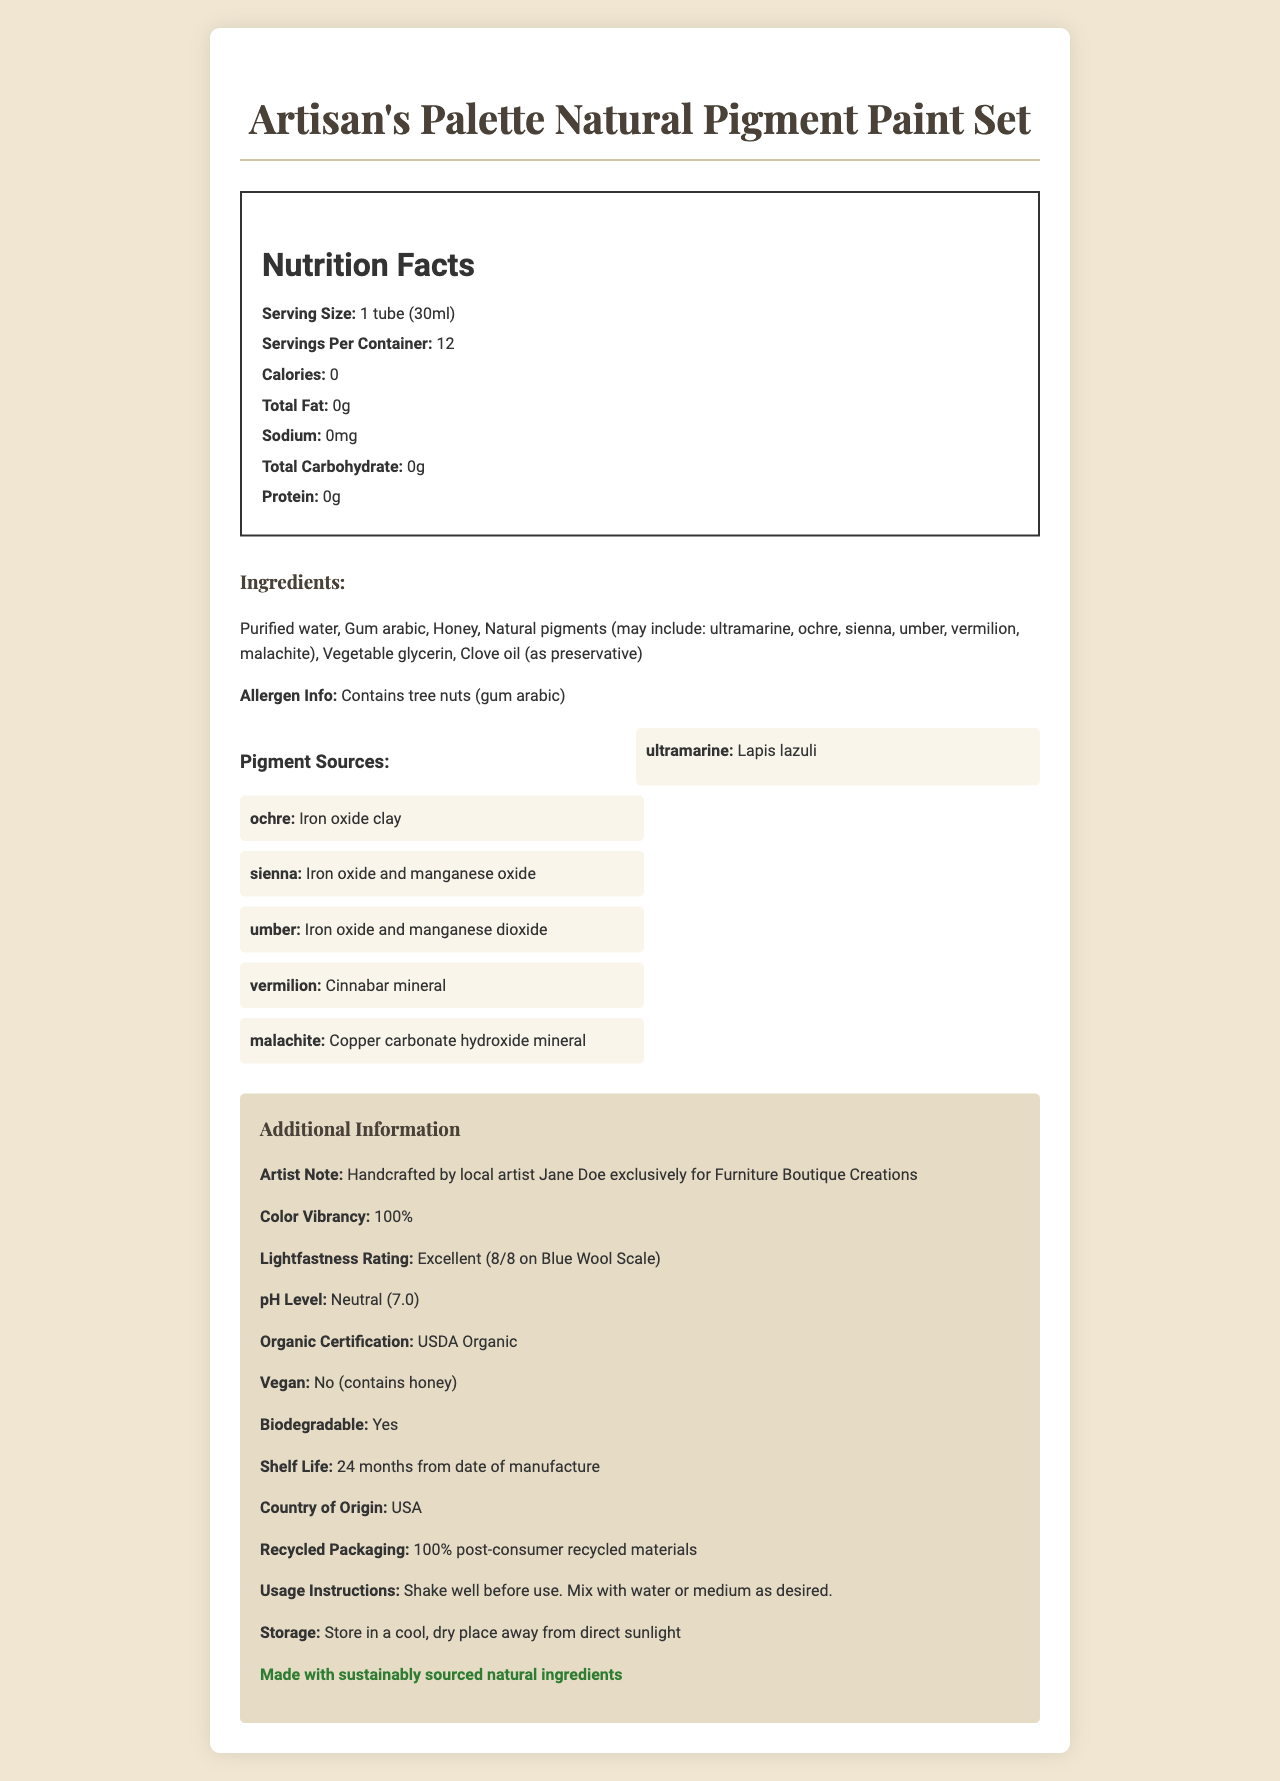what is the serving size of the paint set? The document states that the serving size of the "Artisan's Palette Natural Pigment Paint Set" is 1 tube (30ml).
Answer: 1 tube (30ml) how many servings per container are there? The document specifies that there are 12 servings per container.
Answer: 12 what are the natural pigment sources mentioned in the document? The pigment sources listed in the document for different colors include Lapis lazuli, Iron oxide clay, Iron oxide and manganese oxide, Iron oxide and manganese dioxide, Cinnabar mineral, and Copper carbonate hydroxide mineral.
Answer: Lapis lazuli, Iron oxide clay, Iron oxide and manganese oxide, Iron oxide and manganese dioxide, Cinnabar mineral, Copper carbonate hydroxide mineral who handcrafted the paint set? According to the artist note in the document, the paint set was handcrafted by local artist Jane Doe exclusively for Furniture Boutique Creations.
Answer: Jane Doe what is the lightfastness rating of the paint set? The document mentions that the lightfastness rating of the paint set is Excellent, rated 8/8 on the Blue Wool Scale.
Answer: Excellent (8/8 on Blue Wool Scale) which of the following ingredients is used as a preservative in the paint set? A. Honey B. Vegetable glycerin C. Clove oil D. Purified water The document lists clove oil as the preservative among the ingredients.
Answer: C. Clove oil what is the pH level of the paint set? A. Acidic (5.5) B. Neutral (7.0) C. Alkaline (8.5) The document indicates that the pH level of the paint set is Neutral (7.0).
Answer: B. Neutral (7.0) does the paint set contain any tree nuts? The document specifies in the allergen information section that the paint set contains tree nuts (gum arabic).
Answer: Yes is the paint set vegan-friendly? The document explicitly states that the paint set is not vegan as it contains honey.
Answer: No describe the entire document. The document showcases the Artisan's Palette Natural Pigment Paint Set, highlighting various attributes such as serving size, ingredient list, pigment sources, artist note, and eco-friendly aspects. It covers both the nutritional details, despite them being mostly zero, and additional product characteristics important to potential users and buyers.
Answer: The document provides detailed information about the Artisan's Palette Natural Pigment Paint Set, including nutritional facts, ingredients, allergen info, pigment sources, additional information like artist note, color vibrancy, lightfastness rating, pH level, organic certification, vegan status, biodegradability, shelf life, country of origin, recycled packaging, usage instructions, and storage guidelines. It is presented in a structured and visually appealing format. what's the biocompatibility certification of the paint set? The document does not provide any details or mention any certification related to biocompatibility.
Answer: Not enough information 